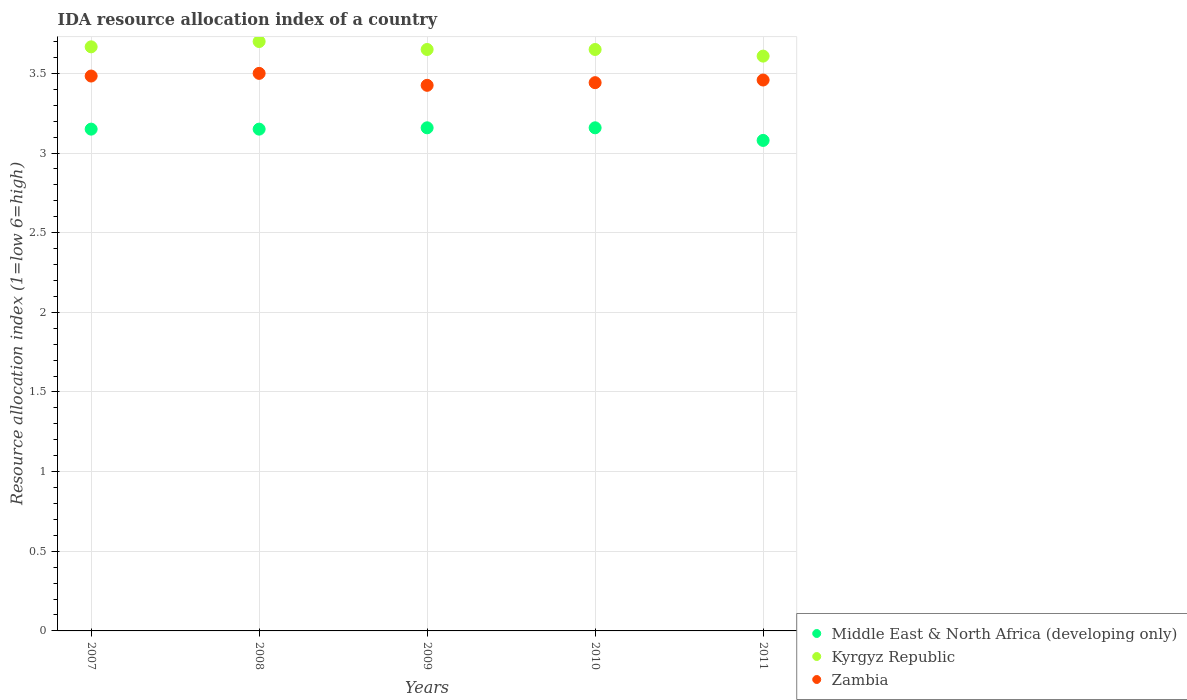Is the number of dotlines equal to the number of legend labels?
Your response must be concise. Yes. What is the IDA resource allocation index in Zambia in 2010?
Your response must be concise. 3.44. Across all years, what is the maximum IDA resource allocation index in Zambia?
Offer a terse response. 3.5. Across all years, what is the minimum IDA resource allocation index in Zambia?
Provide a short and direct response. 3.42. In which year was the IDA resource allocation index in Kyrgyz Republic maximum?
Offer a terse response. 2008. What is the total IDA resource allocation index in Kyrgyz Republic in the graph?
Provide a short and direct response. 18.27. What is the difference between the IDA resource allocation index in Kyrgyz Republic in 2008 and that in 2009?
Offer a terse response. 0.05. What is the difference between the IDA resource allocation index in Zambia in 2011 and the IDA resource allocation index in Middle East & North Africa (developing only) in 2009?
Make the answer very short. 0.3. What is the average IDA resource allocation index in Kyrgyz Republic per year?
Your answer should be very brief. 3.65. In the year 2011, what is the difference between the IDA resource allocation index in Kyrgyz Republic and IDA resource allocation index in Middle East & North Africa (developing only)?
Offer a terse response. 0.53. In how many years, is the IDA resource allocation index in Kyrgyz Republic greater than 3.4?
Keep it short and to the point. 5. What is the ratio of the IDA resource allocation index in Middle East & North Africa (developing only) in 2010 to that in 2011?
Your response must be concise. 1.03. What is the difference between the highest and the second highest IDA resource allocation index in Zambia?
Your answer should be very brief. 0.02. What is the difference between the highest and the lowest IDA resource allocation index in Middle East & North Africa (developing only)?
Provide a short and direct response. 0.08. Is the sum of the IDA resource allocation index in Zambia in 2007 and 2009 greater than the maximum IDA resource allocation index in Middle East & North Africa (developing only) across all years?
Your response must be concise. Yes. Does the IDA resource allocation index in Middle East & North Africa (developing only) monotonically increase over the years?
Ensure brevity in your answer.  No. Is the IDA resource allocation index in Kyrgyz Republic strictly greater than the IDA resource allocation index in Middle East & North Africa (developing only) over the years?
Ensure brevity in your answer.  Yes. Is the IDA resource allocation index in Zambia strictly less than the IDA resource allocation index in Kyrgyz Republic over the years?
Your answer should be very brief. Yes. How many dotlines are there?
Provide a short and direct response. 3. What is the difference between two consecutive major ticks on the Y-axis?
Provide a succinct answer. 0.5. Are the values on the major ticks of Y-axis written in scientific E-notation?
Give a very brief answer. No. Does the graph contain any zero values?
Provide a succinct answer. No. Does the graph contain grids?
Provide a short and direct response. Yes. Where does the legend appear in the graph?
Give a very brief answer. Bottom right. What is the title of the graph?
Offer a very short reply. IDA resource allocation index of a country. What is the label or title of the Y-axis?
Provide a short and direct response. Resource allocation index (1=low 6=high). What is the Resource allocation index (1=low 6=high) in Middle East & North Africa (developing only) in 2007?
Provide a short and direct response. 3.15. What is the Resource allocation index (1=low 6=high) in Kyrgyz Republic in 2007?
Provide a succinct answer. 3.67. What is the Resource allocation index (1=low 6=high) in Zambia in 2007?
Provide a short and direct response. 3.48. What is the Resource allocation index (1=low 6=high) of Middle East & North Africa (developing only) in 2008?
Offer a very short reply. 3.15. What is the Resource allocation index (1=low 6=high) in Kyrgyz Republic in 2008?
Offer a terse response. 3.7. What is the Resource allocation index (1=low 6=high) in Zambia in 2008?
Your answer should be compact. 3.5. What is the Resource allocation index (1=low 6=high) in Middle East & North Africa (developing only) in 2009?
Provide a succinct answer. 3.16. What is the Resource allocation index (1=low 6=high) of Kyrgyz Republic in 2009?
Ensure brevity in your answer.  3.65. What is the Resource allocation index (1=low 6=high) in Zambia in 2009?
Your response must be concise. 3.42. What is the Resource allocation index (1=low 6=high) of Middle East & North Africa (developing only) in 2010?
Your response must be concise. 3.16. What is the Resource allocation index (1=low 6=high) of Kyrgyz Republic in 2010?
Make the answer very short. 3.65. What is the Resource allocation index (1=low 6=high) in Zambia in 2010?
Provide a short and direct response. 3.44. What is the Resource allocation index (1=low 6=high) in Middle East & North Africa (developing only) in 2011?
Ensure brevity in your answer.  3.08. What is the Resource allocation index (1=low 6=high) in Kyrgyz Republic in 2011?
Provide a short and direct response. 3.61. What is the Resource allocation index (1=low 6=high) in Zambia in 2011?
Your response must be concise. 3.46. Across all years, what is the maximum Resource allocation index (1=low 6=high) of Middle East & North Africa (developing only)?
Offer a terse response. 3.16. Across all years, what is the minimum Resource allocation index (1=low 6=high) in Middle East & North Africa (developing only)?
Provide a short and direct response. 3.08. Across all years, what is the minimum Resource allocation index (1=low 6=high) of Kyrgyz Republic?
Your answer should be very brief. 3.61. Across all years, what is the minimum Resource allocation index (1=low 6=high) in Zambia?
Provide a short and direct response. 3.42. What is the total Resource allocation index (1=low 6=high) of Middle East & North Africa (developing only) in the graph?
Make the answer very short. 15.7. What is the total Resource allocation index (1=low 6=high) of Kyrgyz Republic in the graph?
Ensure brevity in your answer.  18.27. What is the total Resource allocation index (1=low 6=high) in Zambia in the graph?
Provide a succinct answer. 17.31. What is the difference between the Resource allocation index (1=low 6=high) in Kyrgyz Republic in 2007 and that in 2008?
Your answer should be compact. -0.03. What is the difference between the Resource allocation index (1=low 6=high) of Zambia in 2007 and that in 2008?
Your answer should be very brief. -0.02. What is the difference between the Resource allocation index (1=low 6=high) in Middle East & North Africa (developing only) in 2007 and that in 2009?
Offer a very short reply. -0.01. What is the difference between the Resource allocation index (1=low 6=high) of Kyrgyz Republic in 2007 and that in 2009?
Offer a terse response. 0.02. What is the difference between the Resource allocation index (1=low 6=high) of Zambia in 2007 and that in 2009?
Make the answer very short. 0.06. What is the difference between the Resource allocation index (1=low 6=high) in Middle East & North Africa (developing only) in 2007 and that in 2010?
Offer a very short reply. -0.01. What is the difference between the Resource allocation index (1=low 6=high) in Kyrgyz Republic in 2007 and that in 2010?
Ensure brevity in your answer.  0.02. What is the difference between the Resource allocation index (1=low 6=high) of Zambia in 2007 and that in 2010?
Provide a succinct answer. 0.04. What is the difference between the Resource allocation index (1=low 6=high) of Middle East & North Africa (developing only) in 2007 and that in 2011?
Your answer should be very brief. 0.07. What is the difference between the Resource allocation index (1=low 6=high) in Kyrgyz Republic in 2007 and that in 2011?
Ensure brevity in your answer.  0.06. What is the difference between the Resource allocation index (1=low 6=high) of Zambia in 2007 and that in 2011?
Provide a short and direct response. 0.03. What is the difference between the Resource allocation index (1=low 6=high) of Middle East & North Africa (developing only) in 2008 and that in 2009?
Keep it short and to the point. -0.01. What is the difference between the Resource allocation index (1=low 6=high) of Kyrgyz Republic in 2008 and that in 2009?
Your answer should be compact. 0.05. What is the difference between the Resource allocation index (1=low 6=high) in Zambia in 2008 and that in 2009?
Ensure brevity in your answer.  0.07. What is the difference between the Resource allocation index (1=low 6=high) in Middle East & North Africa (developing only) in 2008 and that in 2010?
Keep it short and to the point. -0.01. What is the difference between the Resource allocation index (1=low 6=high) of Zambia in 2008 and that in 2010?
Your answer should be compact. 0.06. What is the difference between the Resource allocation index (1=low 6=high) in Middle East & North Africa (developing only) in 2008 and that in 2011?
Provide a short and direct response. 0.07. What is the difference between the Resource allocation index (1=low 6=high) in Kyrgyz Republic in 2008 and that in 2011?
Provide a succinct answer. 0.09. What is the difference between the Resource allocation index (1=low 6=high) of Zambia in 2008 and that in 2011?
Offer a very short reply. 0.04. What is the difference between the Resource allocation index (1=low 6=high) in Zambia in 2009 and that in 2010?
Ensure brevity in your answer.  -0.02. What is the difference between the Resource allocation index (1=low 6=high) of Middle East & North Africa (developing only) in 2009 and that in 2011?
Offer a very short reply. 0.08. What is the difference between the Resource allocation index (1=low 6=high) in Kyrgyz Republic in 2009 and that in 2011?
Make the answer very short. 0.04. What is the difference between the Resource allocation index (1=low 6=high) in Zambia in 2009 and that in 2011?
Your answer should be very brief. -0.03. What is the difference between the Resource allocation index (1=low 6=high) in Middle East & North Africa (developing only) in 2010 and that in 2011?
Ensure brevity in your answer.  0.08. What is the difference between the Resource allocation index (1=low 6=high) in Kyrgyz Republic in 2010 and that in 2011?
Keep it short and to the point. 0.04. What is the difference between the Resource allocation index (1=low 6=high) of Zambia in 2010 and that in 2011?
Keep it short and to the point. -0.02. What is the difference between the Resource allocation index (1=low 6=high) in Middle East & North Africa (developing only) in 2007 and the Resource allocation index (1=low 6=high) in Kyrgyz Republic in 2008?
Give a very brief answer. -0.55. What is the difference between the Resource allocation index (1=low 6=high) of Middle East & North Africa (developing only) in 2007 and the Resource allocation index (1=low 6=high) of Zambia in 2008?
Provide a succinct answer. -0.35. What is the difference between the Resource allocation index (1=low 6=high) in Kyrgyz Republic in 2007 and the Resource allocation index (1=low 6=high) in Zambia in 2008?
Make the answer very short. 0.17. What is the difference between the Resource allocation index (1=low 6=high) of Middle East & North Africa (developing only) in 2007 and the Resource allocation index (1=low 6=high) of Zambia in 2009?
Keep it short and to the point. -0.28. What is the difference between the Resource allocation index (1=low 6=high) of Kyrgyz Republic in 2007 and the Resource allocation index (1=low 6=high) of Zambia in 2009?
Keep it short and to the point. 0.24. What is the difference between the Resource allocation index (1=low 6=high) of Middle East & North Africa (developing only) in 2007 and the Resource allocation index (1=low 6=high) of Kyrgyz Republic in 2010?
Provide a succinct answer. -0.5. What is the difference between the Resource allocation index (1=low 6=high) in Middle East & North Africa (developing only) in 2007 and the Resource allocation index (1=low 6=high) in Zambia in 2010?
Offer a very short reply. -0.29. What is the difference between the Resource allocation index (1=low 6=high) in Kyrgyz Republic in 2007 and the Resource allocation index (1=low 6=high) in Zambia in 2010?
Provide a short and direct response. 0.23. What is the difference between the Resource allocation index (1=low 6=high) in Middle East & North Africa (developing only) in 2007 and the Resource allocation index (1=low 6=high) in Kyrgyz Republic in 2011?
Ensure brevity in your answer.  -0.46. What is the difference between the Resource allocation index (1=low 6=high) of Middle East & North Africa (developing only) in 2007 and the Resource allocation index (1=low 6=high) of Zambia in 2011?
Offer a terse response. -0.31. What is the difference between the Resource allocation index (1=low 6=high) in Kyrgyz Republic in 2007 and the Resource allocation index (1=low 6=high) in Zambia in 2011?
Keep it short and to the point. 0.21. What is the difference between the Resource allocation index (1=low 6=high) of Middle East & North Africa (developing only) in 2008 and the Resource allocation index (1=low 6=high) of Kyrgyz Republic in 2009?
Offer a terse response. -0.5. What is the difference between the Resource allocation index (1=low 6=high) in Middle East & North Africa (developing only) in 2008 and the Resource allocation index (1=low 6=high) in Zambia in 2009?
Your answer should be compact. -0.28. What is the difference between the Resource allocation index (1=low 6=high) of Kyrgyz Republic in 2008 and the Resource allocation index (1=low 6=high) of Zambia in 2009?
Your answer should be compact. 0.28. What is the difference between the Resource allocation index (1=low 6=high) in Middle East & North Africa (developing only) in 2008 and the Resource allocation index (1=low 6=high) in Kyrgyz Republic in 2010?
Your answer should be very brief. -0.5. What is the difference between the Resource allocation index (1=low 6=high) of Middle East & North Africa (developing only) in 2008 and the Resource allocation index (1=low 6=high) of Zambia in 2010?
Provide a short and direct response. -0.29. What is the difference between the Resource allocation index (1=low 6=high) in Kyrgyz Republic in 2008 and the Resource allocation index (1=low 6=high) in Zambia in 2010?
Your response must be concise. 0.26. What is the difference between the Resource allocation index (1=low 6=high) in Middle East & North Africa (developing only) in 2008 and the Resource allocation index (1=low 6=high) in Kyrgyz Republic in 2011?
Offer a terse response. -0.46. What is the difference between the Resource allocation index (1=low 6=high) of Middle East & North Africa (developing only) in 2008 and the Resource allocation index (1=low 6=high) of Zambia in 2011?
Provide a short and direct response. -0.31. What is the difference between the Resource allocation index (1=low 6=high) of Kyrgyz Republic in 2008 and the Resource allocation index (1=low 6=high) of Zambia in 2011?
Make the answer very short. 0.24. What is the difference between the Resource allocation index (1=low 6=high) in Middle East & North Africa (developing only) in 2009 and the Resource allocation index (1=low 6=high) in Kyrgyz Republic in 2010?
Offer a very short reply. -0.49. What is the difference between the Resource allocation index (1=low 6=high) of Middle East & North Africa (developing only) in 2009 and the Resource allocation index (1=low 6=high) of Zambia in 2010?
Your response must be concise. -0.28. What is the difference between the Resource allocation index (1=low 6=high) of Kyrgyz Republic in 2009 and the Resource allocation index (1=low 6=high) of Zambia in 2010?
Offer a very short reply. 0.21. What is the difference between the Resource allocation index (1=low 6=high) of Middle East & North Africa (developing only) in 2009 and the Resource allocation index (1=low 6=high) of Kyrgyz Republic in 2011?
Give a very brief answer. -0.45. What is the difference between the Resource allocation index (1=low 6=high) of Kyrgyz Republic in 2009 and the Resource allocation index (1=low 6=high) of Zambia in 2011?
Make the answer very short. 0.19. What is the difference between the Resource allocation index (1=low 6=high) in Middle East & North Africa (developing only) in 2010 and the Resource allocation index (1=low 6=high) in Kyrgyz Republic in 2011?
Your response must be concise. -0.45. What is the difference between the Resource allocation index (1=low 6=high) in Kyrgyz Republic in 2010 and the Resource allocation index (1=low 6=high) in Zambia in 2011?
Offer a very short reply. 0.19. What is the average Resource allocation index (1=low 6=high) of Middle East & North Africa (developing only) per year?
Ensure brevity in your answer.  3.14. What is the average Resource allocation index (1=low 6=high) of Kyrgyz Republic per year?
Your response must be concise. 3.65. What is the average Resource allocation index (1=low 6=high) of Zambia per year?
Your answer should be compact. 3.46. In the year 2007, what is the difference between the Resource allocation index (1=low 6=high) in Middle East & North Africa (developing only) and Resource allocation index (1=low 6=high) in Kyrgyz Republic?
Ensure brevity in your answer.  -0.52. In the year 2007, what is the difference between the Resource allocation index (1=low 6=high) of Kyrgyz Republic and Resource allocation index (1=low 6=high) of Zambia?
Provide a succinct answer. 0.18. In the year 2008, what is the difference between the Resource allocation index (1=low 6=high) in Middle East & North Africa (developing only) and Resource allocation index (1=low 6=high) in Kyrgyz Republic?
Your answer should be very brief. -0.55. In the year 2008, what is the difference between the Resource allocation index (1=low 6=high) of Middle East & North Africa (developing only) and Resource allocation index (1=low 6=high) of Zambia?
Make the answer very short. -0.35. In the year 2009, what is the difference between the Resource allocation index (1=low 6=high) in Middle East & North Africa (developing only) and Resource allocation index (1=low 6=high) in Kyrgyz Republic?
Your answer should be very brief. -0.49. In the year 2009, what is the difference between the Resource allocation index (1=low 6=high) of Middle East & North Africa (developing only) and Resource allocation index (1=low 6=high) of Zambia?
Keep it short and to the point. -0.27. In the year 2009, what is the difference between the Resource allocation index (1=low 6=high) of Kyrgyz Republic and Resource allocation index (1=low 6=high) of Zambia?
Offer a very short reply. 0.23. In the year 2010, what is the difference between the Resource allocation index (1=low 6=high) in Middle East & North Africa (developing only) and Resource allocation index (1=low 6=high) in Kyrgyz Republic?
Your answer should be compact. -0.49. In the year 2010, what is the difference between the Resource allocation index (1=low 6=high) of Middle East & North Africa (developing only) and Resource allocation index (1=low 6=high) of Zambia?
Your response must be concise. -0.28. In the year 2010, what is the difference between the Resource allocation index (1=low 6=high) in Kyrgyz Republic and Resource allocation index (1=low 6=high) in Zambia?
Provide a short and direct response. 0.21. In the year 2011, what is the difference between the Resource allocation index (1=low 6=high) in Middle East & North Africa (developing only) and Resource allocation index (1=low 6=high) in Kyrgyz Republic?
Give a very brief answer. -0.53. In the year 2011, what is the difference between the Resource allocation index (1=low 6=high) in Middle East & North Africa (developing only) and Resource allocation index (1=low 6=high) in Zambia?
Offer a terse response. -0.38. What is the ratio of the Resource allocation index (1=low 6=high) in Middle East & North Africa (developing only) in 2007 to that in 2008?
Offer a very short reply. 1. What is the ratio of the Resource allocation index (1=low 6=high) in Kyrgyz Republic in 2007 to that in 2008?
Offer a terse response. 0.99. What is the ratio of the Resource allocation index (1=low 6=high) in Kyrgyz Republic in 2007 to that in 2009?
Give a very brief answer. 1. What is the ratio of the Resource allocation index (1=low 6=high) of Zambia in 2007 to that in 2009?
Keep it short and to the point. 1.02. What is the ratio of the Resource allocation index (1=low 6=high) of Middle East & North Africa (developing only) in 2007 to that in 2010?
Provide a short and direct response. 1. What is the ratio of the Resource allocation index (1=low 6=high) of Zambia in 2007 to that in 2010?
Your response must be concise. 1.01. What is the ratio of the Resource allocation index (1=low 6=high) in Middle East & North Africa (developing only) in 2007 to that in 2011?
Keep it short and to the point. 1.02. What is the ratio of the Resource allocation index (1=low 6=high) of Kyrgyz Republic in 2007 to that in 2011?
Offer a terse response. 1.02. What is the ratio of the Resource allocation index (1=low 6=high) in Middle East & North Africa (developing only) in 2008 to that in 2009?
Offer a terse response. 1. What is the ratio of the Resource allocation index (1=low 6=high) of Kyrgyz Republic in 2008 to that in 2009?
Provide a succinct answer. 1.01. What is the ratio of the Resource allocation index (1=low 6=high) in Zambia in 2008 to that in 2009?
Offer a very short reply. 1.02. What is the ratio of the Resource allocation index (1=low 6=high) of Middle East & North Africa (developing only) in 2008 to that in 2010?
Offer a terse response. 1. What is the ratio of the Resource allocation index (1=low 6=high) of Kyrgyz Republic in 2008 to that in 2010?
Ensure brevity in your answer.  1.01. What is the ratio of the Resource allocation index (1=low 6=high) in Zambia in 2008 to that in 2010?
Your answer should be compact. 1.02. What is the ratio of the Resource allocation index (1=low 6=high) of Middle East & North Africa (developing only) in 2008 to that in 2011?
Your answer should be compact. 1.02. What is the ratio of the Resource allocation index (1=low 6=high) of Kyrgyz Republic in 2008 to that in 2011?
Make the answer very short. 1.03. What is the ratio of the Resource allocation index (1=low 6=high) in Zambia in 2008 to that in 2011?
Make the answer very short. 1.01. What is the ratio of the Resource allocation index (1=low 6=high) in Middle East & North Africa (developing only) in 2009 to that in 2010?
Your answer should be very brief. 1. What is the ratio of the Resource allocation index (1=low 6=high) in Kyrgyz Republic in 2009 to that in 2010?
Provide a succinct answer. 1. What is the ratio of the Resource allocation index (1=low 6=high) in Middle East & North Africa (developing only) in 2009 to that in 2011?
Give a very brief answer. 1.03. What is the ratio of the Resource allocation index (1=low 6=high) in Kyrgyz Republic in 2009 to that in 2011?
Ensure brevity in your answer.  1.01. What is the ratio of the Resource allocation index (1=low 6=high) in Zambia in 2009 to that in 2011?
Your answer should be very brief. 0.99. What is the ratio of the Resource allocation index (1=low 6=high) in Middle East & North Africa (developing only) in 2010 to that in 2011?
Ensure brevity in your answer.  1.03. What is the ratio of the Resource allocation index (1=low 6=high) of Kyrgyz Republic in 2010 to that in 2011?
Keep it short and to the point. 1.01. What is the ratio of the Resource allocation index (1=low 6=high) in Zambia in 2010 to that in 2011?
Provide a succinct answer. 1. What is the difference between the highest and the second highest Resource allocation index (1=low 6=high) in Middle East & North Africa (developing only)?
Provide a short and direct response. 0. What is the difference between the highest and the second highest Resource allocation index (1=low 6=high) of Kyrgyz Republic?
Give a very brief answer. 0.03. What is the difference between the highest and the second highest Resource allocation index (1=low 6=high) of Zambia?
Your answer should be very brief. 0.02. What is the difference between the highest and the lowest Resource allocation index (1=low 6=high) of Middle East & North Africa (developing only)?
Provide a short and direct response. 0.08. What is the difference between the highest and the lowest Resource allocation index (1=low 6=high) of Kyrgyz Republic?
Ensure brevity in your answer.  0.09. What is the difference between the highest and the lowest Resource allocation index (1=low 6=high) of Zambia?
Offer a very short reply. 0.07. 